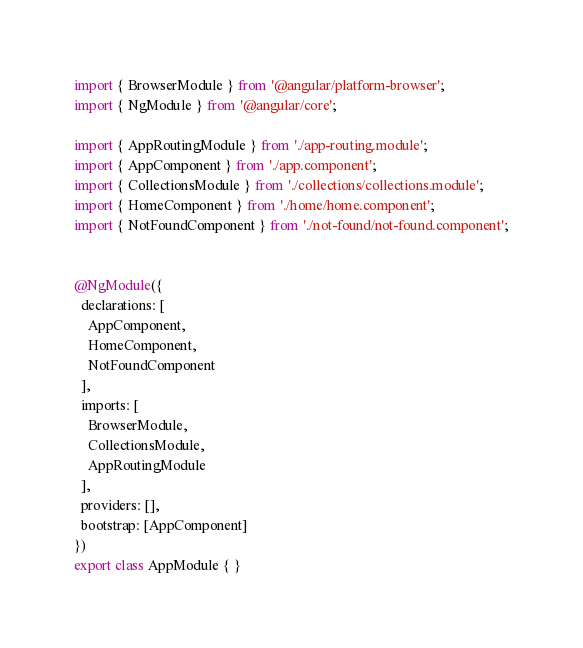<code> <loc_0><loc_0><loc_500><loc_500><_TypeScript_>import { BrowserModule } from '@angular/platform-browser';
import { NgModule } from '@angular/core';

import { AppRoutingModule } from './app-routing.module';
import { AppComponent } from './app.component';
import { CollectionsModule } from './collections/collections.module';
import { HomeComponent } from './home/home.component';
import { NotFoundComponent } from './not-found/not-found.component';


@NgModule({
  declarations: [
    AppComponent,
    HomeComponent,
    NotFoundComponent
  ],
  imports: [
    BrowserModule,
    CollectionsModule,
    AppRoutingModule
  ],
  providers: [],
  bootstrap: [AppComponent]
})
export class AppModule { }
</code> 